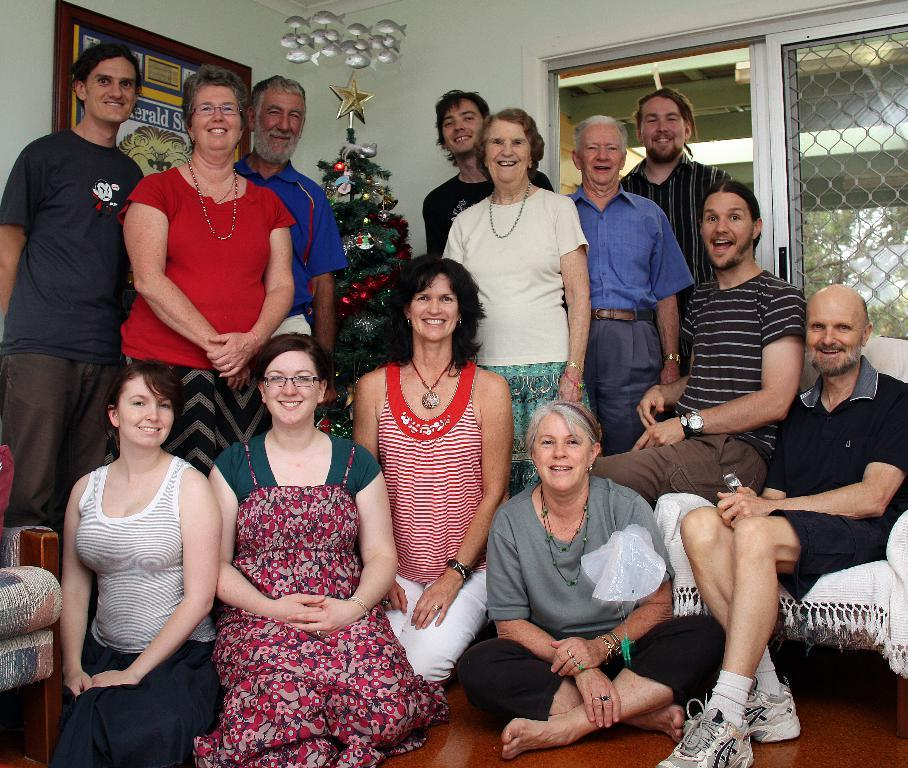What are the people in the image doing? Some people are standing, and others are sitting in the image. What is the main decoration in the image? There is a Christmas tree in the image. What can be seen through the windows in the image? The windows in the image provide a view of the surroundings. How is the frame of the image attached to the wall? The frame is attached to the wall in the image. What type of farm animals can be seen on the tongue of the person in the image? There are no farm animals or tongues visible in the image. 